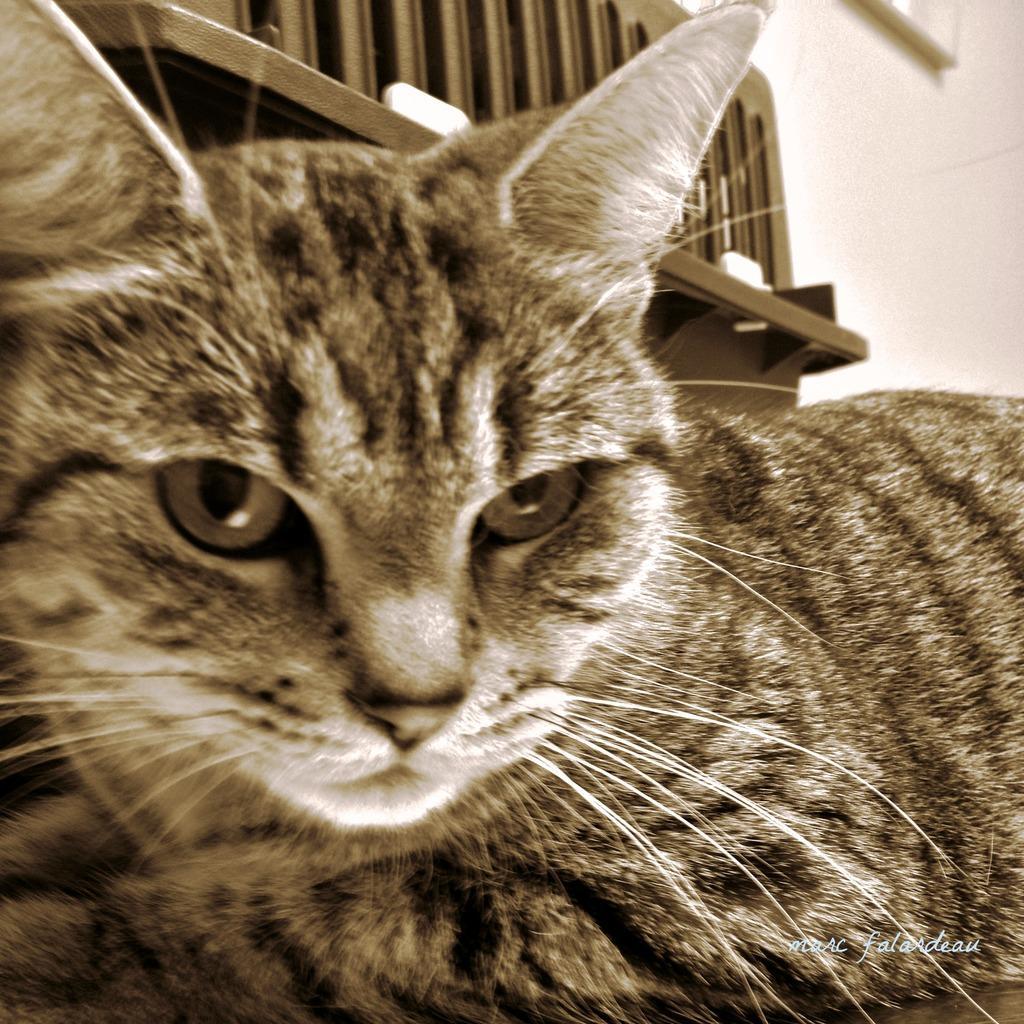How would you summarize this image in a sentence or two? In the foreground of this image, there is a cat. In the background, it seems like a bench and a wall. 